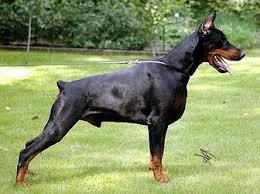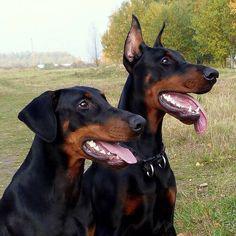The first image is the image on the left, the second image is the image on the right. Considering the images on both sides, is "One image shows side-by-side dobermans with at least one having erect ears, and the other image shows one rightward-turned doberman with docked tail and erect pointy ears." valid? Answer yes or no. Yes. The first image is the image on the left, the second image is the image on the right. Evaluate the accuracy of this statement regarding the images: "At least one doberman has its tongue out.". Is it true? Answer yes or no. Yes. 